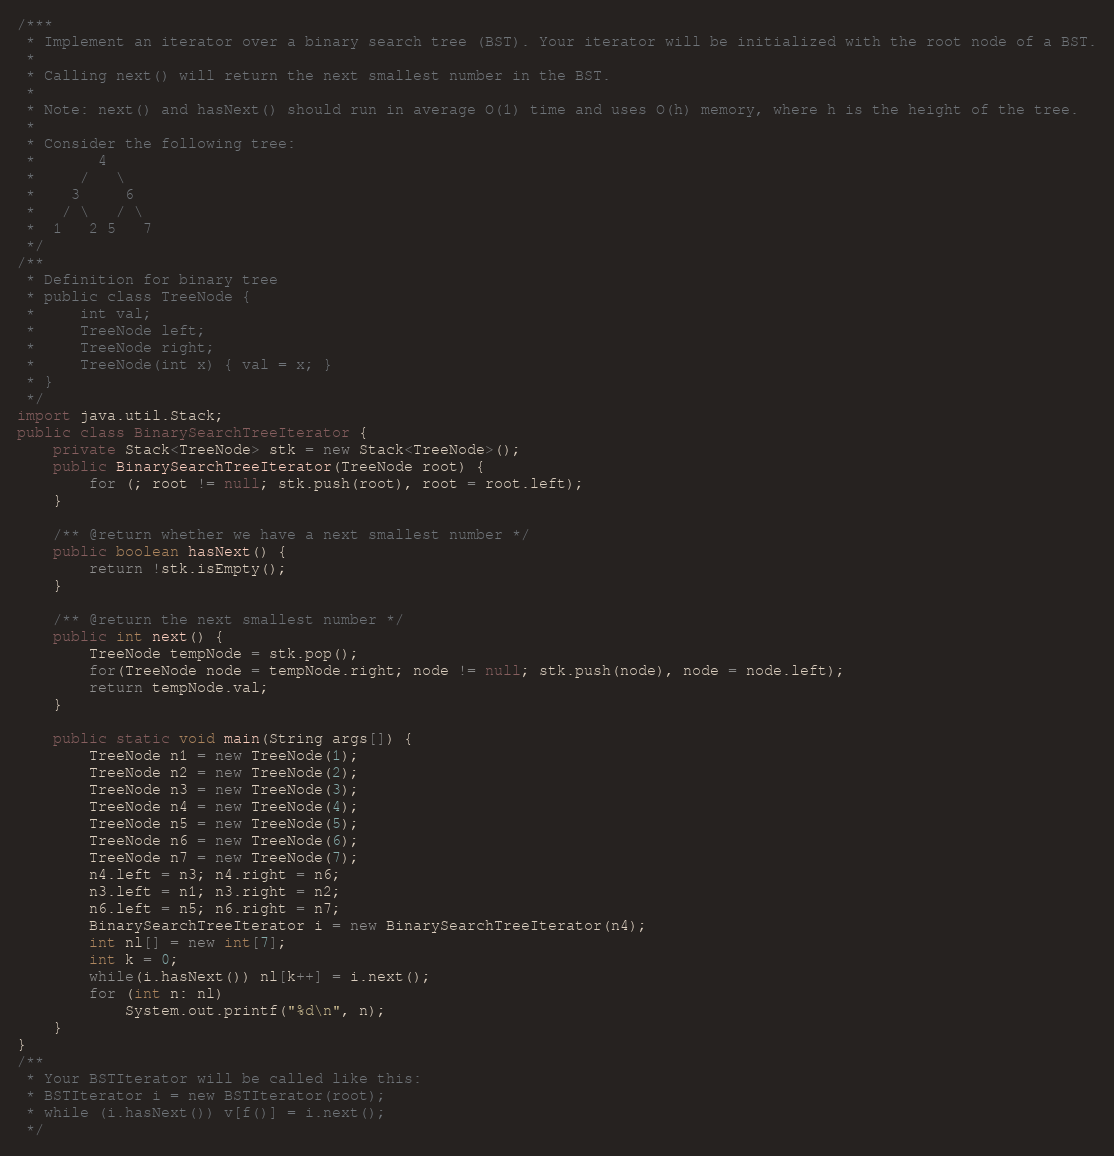<code> <loc_0><loc_0><loc_500><loc_500><_Java_>/***
 * Implement an iterator over a binary search tree (BST). Your iterator will be initialized with the root node of a BST.
 *
 * Calling next() will return the next smallest number in the BST.
 *
 * Note: next() and hasNext() should run in average O(1) time and uses O(h) memory, where h is the height of the tree.
 *
 * Consider the following tree:
 *       4
 *     /   \
 *    3     6
 *   / \   / \
 *  1   2 5   7
 */
/**
 * Definition for binary tree
 * public class TreeNode {
 *     int val;
 *     TreeNode left;
 *     TreeNode right;
 *     TreeNode(int x) { val = x; }
 * }
 */
import java.util.Stack;
public class BinarySearchTreeIterator {
    private Stack<TreeNode> stk = new Stack<TreeNode>();
    public BinarySearchTreeIterator(TreeNode root) {
        for (; root != null; stk.push(root), root = root.left);
    }

    /** @return whether we have a next smallest number */
    public boolean hasNext() {
        return !stk.isEmpty();
    }

    /** @return the next smallest number */
    public int next() {
        TreeNode tempNode = stk.pop();
        for(TreeNode node = tempNode.right; node != null; stk.push(node), node = node.left);
        return tempNode.val;
    }

    public static void main(String args[]) {
        TreeNode n1 = new TreeNode(1);
        TreeNode n2 = new TreeNode(2);
        TreeNode n3 = new TreeNode(3);
        TreeNode n4 = new TreeNode(4);
        TreeNode n5 = new TreeNode(5);
        TreeNode n6 = new TreeNode(6);
        TreeNode n7 = new TreeNode(7);
        n4.left = n3; n4.right = n6;
        n3.left = n1; n3.right = n2;
        n6.left = n5; n6.right = n7;
        BinarySearchTreeIterator i = new BinarySearchTreeIterator(n4);
        int nl[] = new int[7];
        int k = 0;
        while(i.hasNext()) nl[k++] = i.next();
        for (int n: nl)
            System.out.printf("%d\n", n);
    }
}
/**
 * Your BSTIterator will be called like this:
 * BSTIterator i = new BSTIterator(root);
 * while (i.hasNext()) v[f()] = i.next();
 */
</code> 